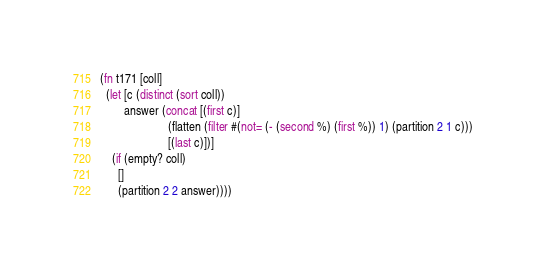<code> <loc_0><loc_0><loc_500><loc_500><_Clojure_>(fn t171 [coll]
  (let [c (distinct (sort coll))
        answer (concat [(first c)]
                       (flatten (filter #(not= (- (second %) (first %)) 1) (partition 2 1 c)))
                       [(last c)])]
    (if (empty? coll)
      []
      (partition 2 2 answer))))</code> 